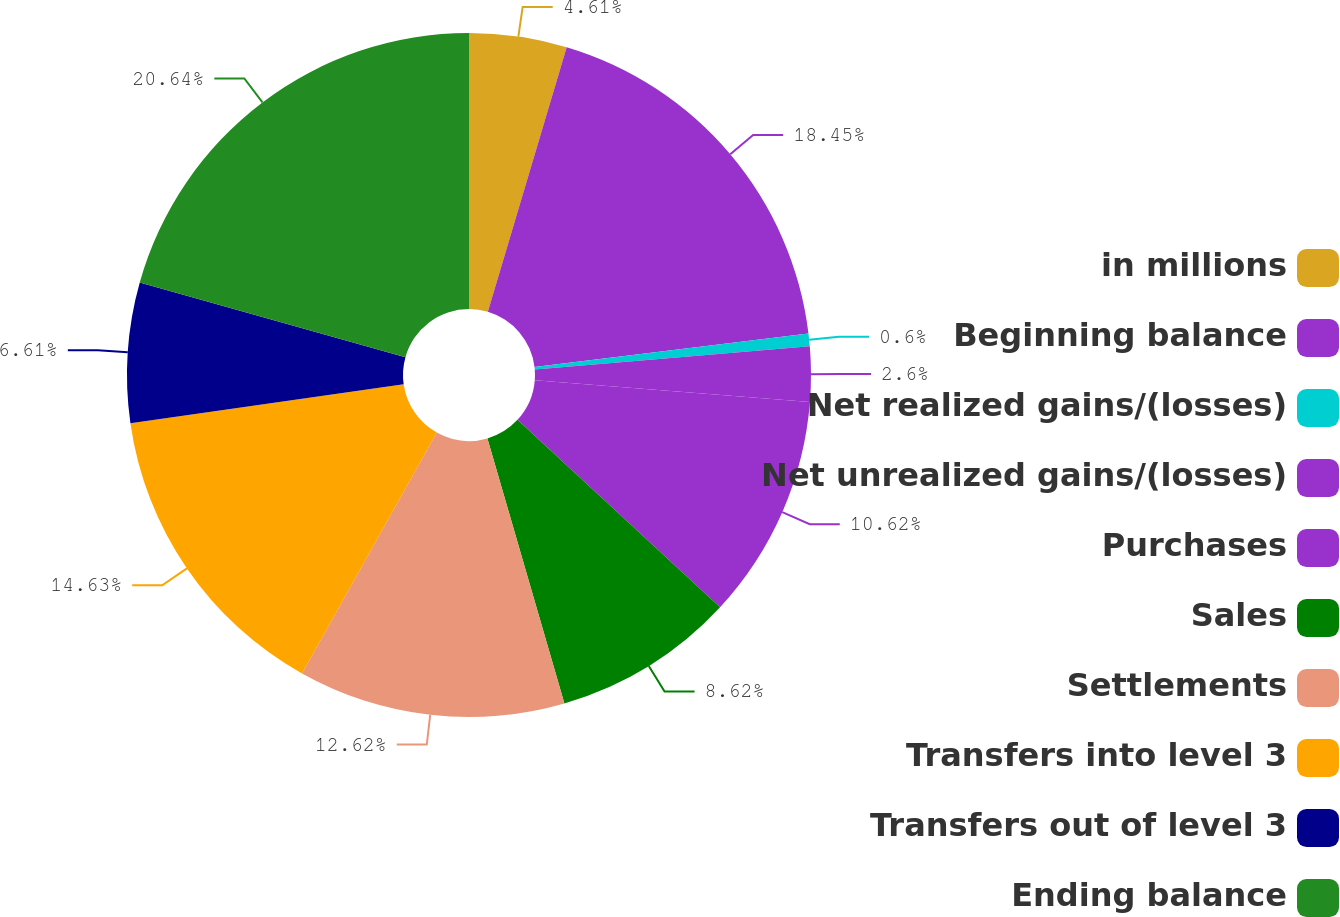Convert chart. <chart><loc_0><loc_0><loc_500><loc_500><pie_chart><fcel>in millions<fcel>Beginning balance<fcel>Net realized gains/(losses)<fcel>Net unrealized gains/(losses)<fcel>Purchases<fcel>Sales<fcel>Settlements<fcel>Transfers into level 3<fcel>Transfers out of level 3<fcel>Ending balance<nl><fcel>4.61%<fcel>18.45%<fcel>0.6%<fcel>2.6%<fcel>10.62%<fcel>8.62%<fcel>12.62%<fcel>14.63%<fcel>6.61%<fcel>20.64%<nl></chart> 